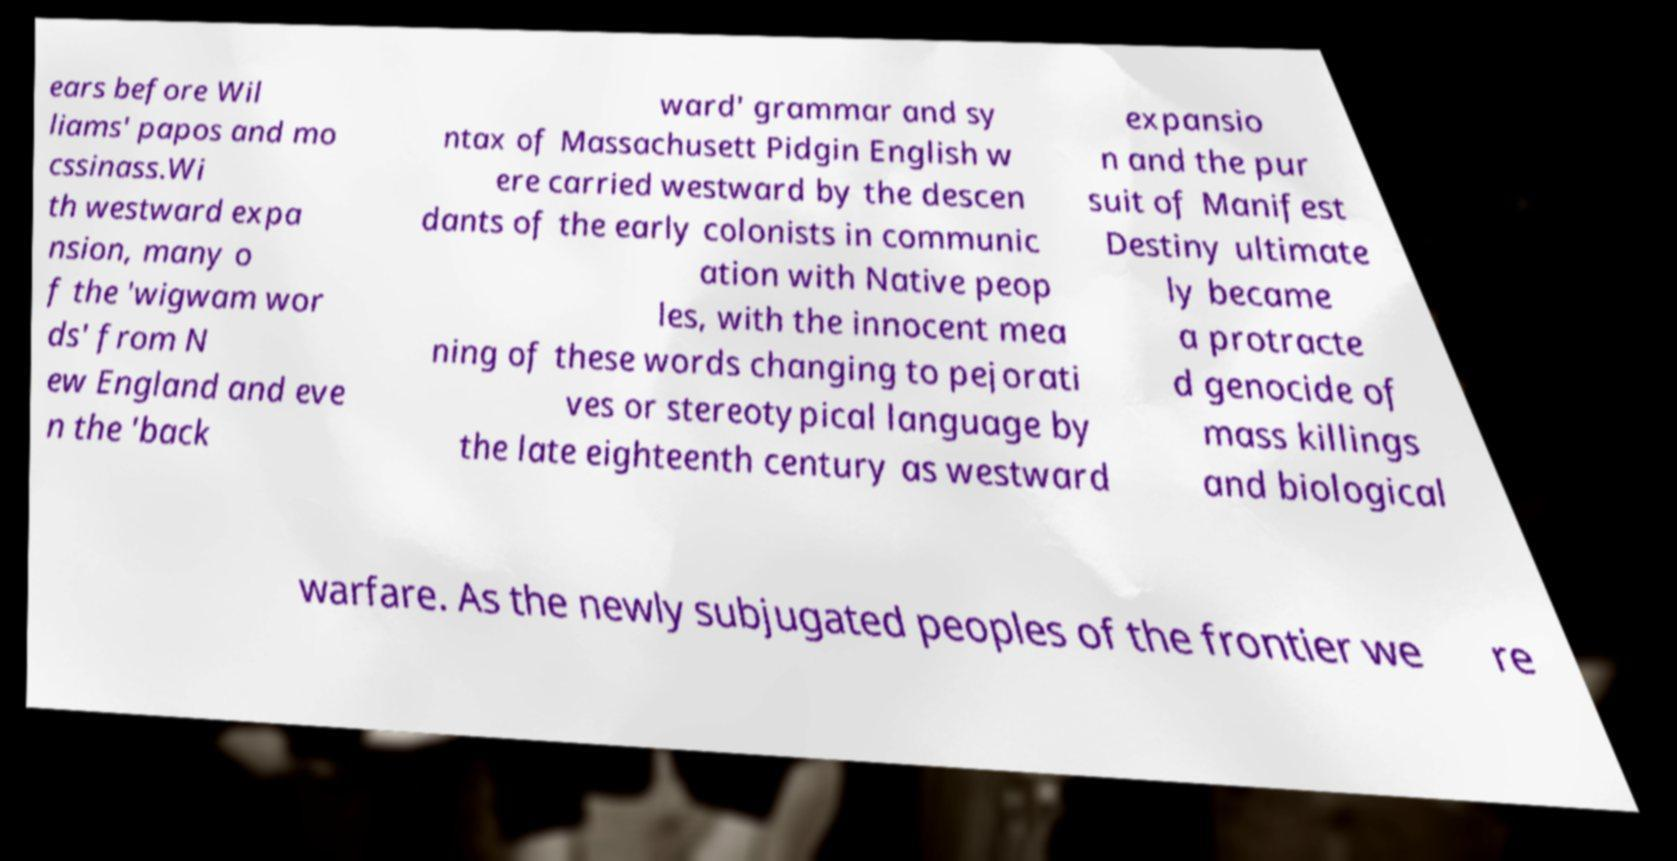Please read and relay the text visible in this image. What does it say? ears before Wil liams' papos and mo cssinass.Wi th westward expa nsion, many o f the 'wigwam wor ds' from N ew England and eve n the 'back ward' grammar and sy ntax of Massachusett Pidgin English w ere carried westward by the descen dants of the early colonists in communic ation with Native peop les, with the innocent mea ning of these words changing to pejorati ves or stereotypical language by the late eighteenth century as westward expansio n and the pur suit of Manifest Destiny ultimate ly became a protracte d genocide of mass killings and biological warfare. As the newly subjugated peoples of the frontier we re 